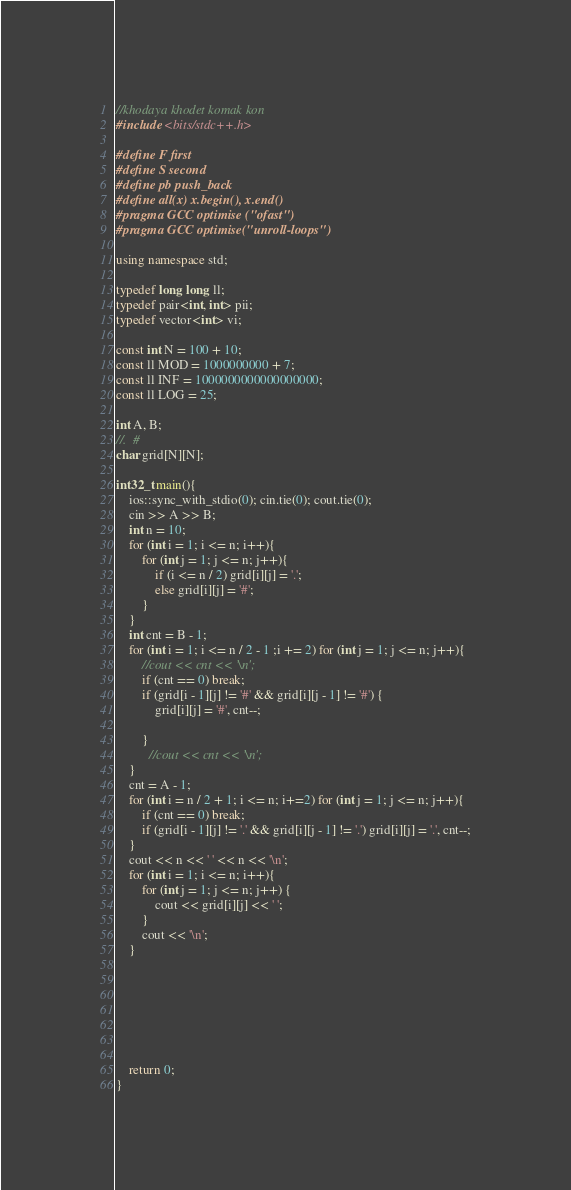Convert code to text. <code><loc_0><loc_0><loc_500><loc_500><_C++_>//khodaya khodet komak kon
#include <bits/stdc++.h>
 
#define F first
#define S second
#define pb push_back
#define all(x) x.begin(), x.end()
#pragma GCC optimise ("ofast")
#pragma GCC optimise("unroll-loops")
 
using namespace std;
 
typedef long long ll;
typedef pair<int, int> pii;
typedef vector<int> vi;
 
const int N = 100 + 10;
const ll MOD = 1000000000 + 7;
const ll INF = 1000000000000000000;
const ll LOG = 25;
 
int A, B;
//.  #
char grid[N][N];
 
int32_t main(){
	ios::sync_with_stdio(0); cin.tie(0); cout.tie(0);
	cin >> A >> B;
  	int n = 10;
	for (int i = 1; i <= n; i++){
		for (int j = 1; j <= n; j++){
			if (i <= n / 2) grid[i][j] = '.';
			else grid[i][j] = '#';
		}
	}
	int cnt = B - 1;
	for (int i = 1; i <= n / 2 - 1 ;i += 2) for (int j = 1; j <= n; j++){
		//cout << cnt << '\n';
     	if (cnt == 0) break;
		if (grid[i - 1][j] != '#' && grid[i][j - 1] != '#') {
          	grid[i][j] = '#', cnt--;
        	
        }
          //cout << cnt << '\n';
    }
	cnt = A - 1;
	for (int i = n / 2 + 1; i <= n; i+=2) for (int j = 1; j <= n; j++){
		if (cnt == 0) break;
		if (grid[i - 1][j] != '.' && grid[i][j - 1] != '.') grid[i][j] = '.', cnt--;
	}
	cout << n << ' ' << n << '\n';
	for (int i = 1; i <= n; i++){
		for (int j = 1; j <= n; j++) {
			cout << grid[i][j] << ' ';
		}
		cout << '\n';
	}
 
 
 
 
 
 
 
	return 0;
}</code> 